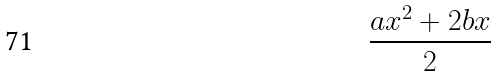Convert formula to latex. <formula><loc_0><loc_0><loc_500><loc_500>\frac { a x ^ { 2 } + 2 b x } { 2 }</formula> 